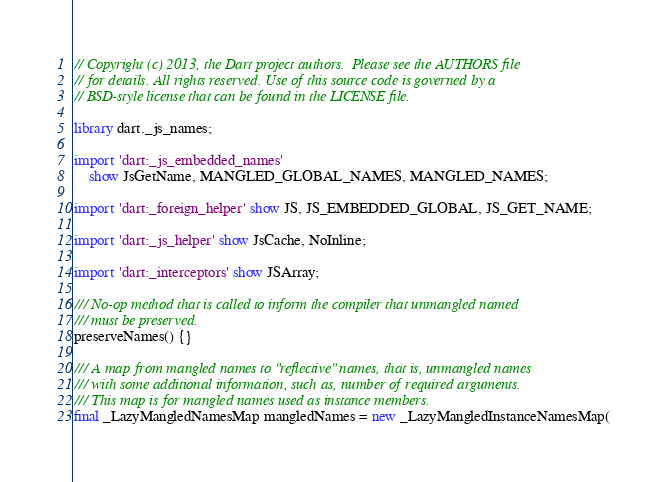Convert code to text. <code><loc_0><loc_0><loc_500><loc_500><_Dart_>// Copyright (c) 2013, the Dart project authors.  Please see the AUTHORS file
// for details. All rights reserved. Use of this source code is governed by a
// BSD-style license that can be found in the LICENSE file.

library dart._js_names;

import 'dart:_js_embedded_names'
    show JsGetName, MANGLED_GLOBAL_NAMES, MANGLED_NAMES;

import 'dart:_foreign_helper' show JS, JS_EMBEDDED_GLOBAL, JS_GET_NAME;

import 'dart:_js_helper' show JsCache, NoInline;

import 'dart:_interceptors' show JSArray;

/// No-op method that is called to inform the compiler that unmangled named
/// must be preserved.
preserveNames() {}

/// A map from mangled names to "reflective" names, that is, unmangled names
/// with some additional information, such as, number of required arguments.
/// This map is for mangled names used as instance members.
final _LazyMangledNamesMap mangledNames = new _LazyMangledInstanceNamesMap(</code> 